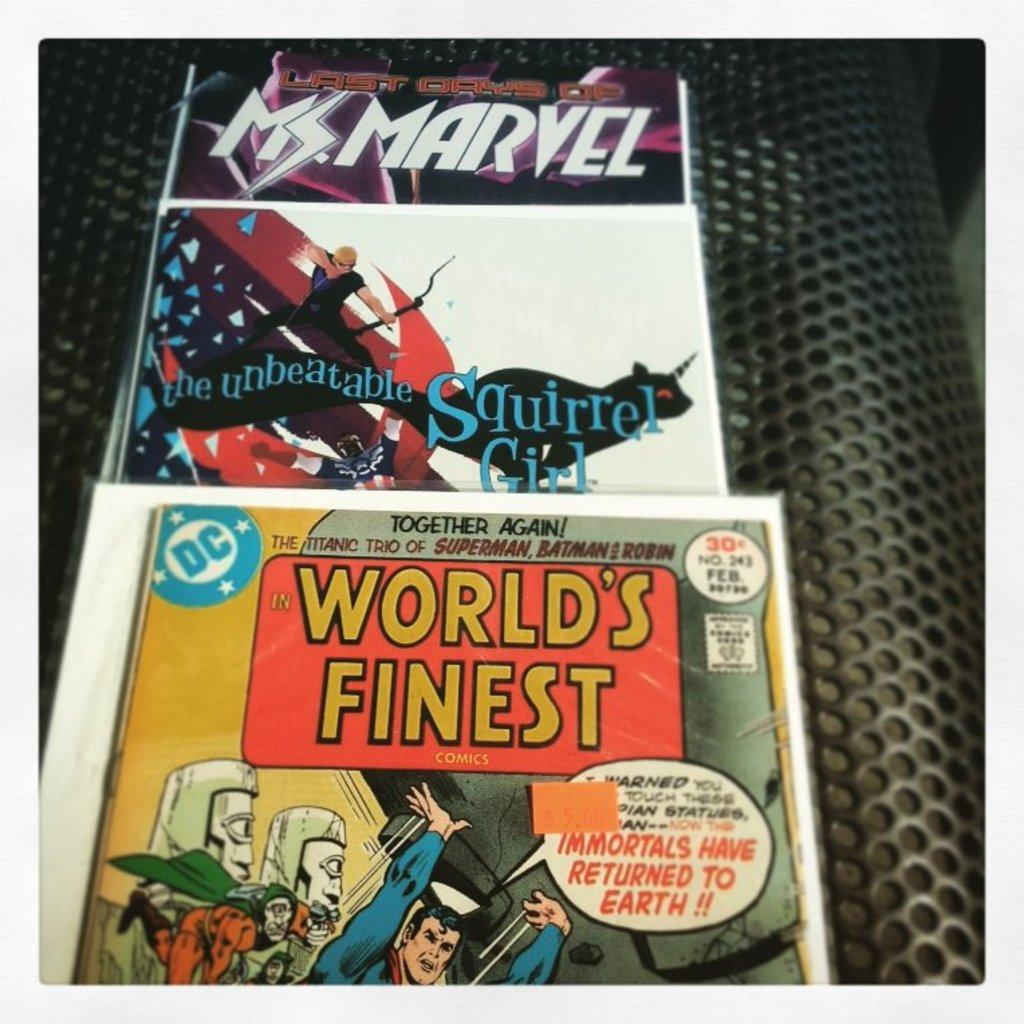<image>
Render a clear and concise summary of the photo. Three comic books, one of them called world's finest with Superman on the cover. 